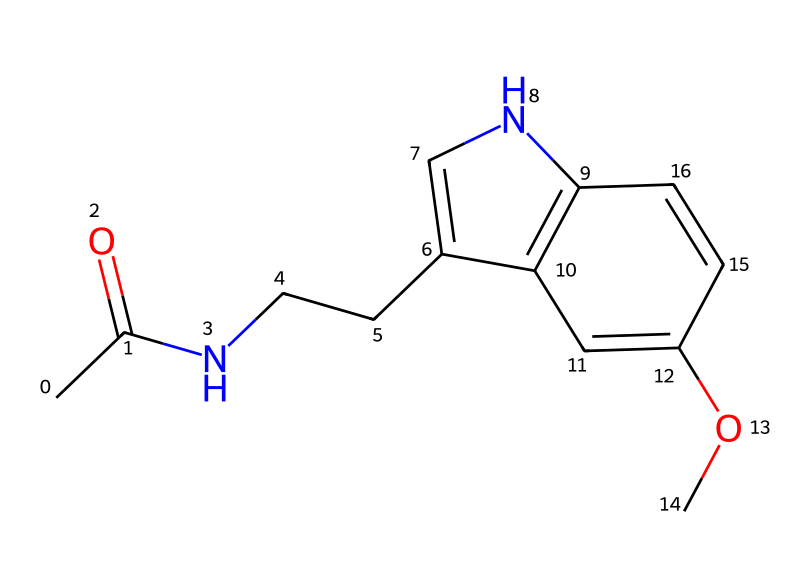What is the IUPAC name of this chemical? The chemical's SMILES representation shows a structure with specific functional groups. By examining the components and connectivity, we can deduce the IUPAC name as N-acetyl-5-methoxytryptamine, which is derived from the main substructures identified in the analysis.
Answer: N-acetyl-5-methoxytryptamine How many carbon atoms are in this structure? By analyzing the SMILES representation, we can count the carbon atoms present. Each "C" and "c" corresponds to a carbon atom, and we identify a total of 13 carbon atoms in the structure.
Answer: 13 What type of functional group is present at the end of the side chain? The side chain features a carbonyl (C=O) group, which indicates the presence of an amide functional group due to the nitrogen attachment. This is characteristic of compounds related to proteins and hormones.
Answer: carbonyl Which element is represented by the atom symbol 'N'? In the structure, 'N' clearly represents nitrogen, which is a common atom found in many biochemical compounds, particularly those related to amino acids and neurotransmitters like melatonin.
Answer: nitrogen What is the molecular formula of this compound? To derive the molecular formula, we total the number of each type of atom: 13 carbons, 16 hydrogens, 2 nitrogens, and 1 oxygen. This combines into the molecular formula C13H16N2O.
Answer: C13H16N2O How many nitrogen atoms are present in the chemical structure? In the SMILES representation, 'N' appears twice, indicating that there are two nitrogen atoms present in the molecule.
Answer: 2 What type of compound is melatonin classified as? Given the structure, melatonin is classified as an indoleamine, which reflects its derivation from the tryptophan amino acid and its involvement in regulating sleep.
Answer: indoleamine 